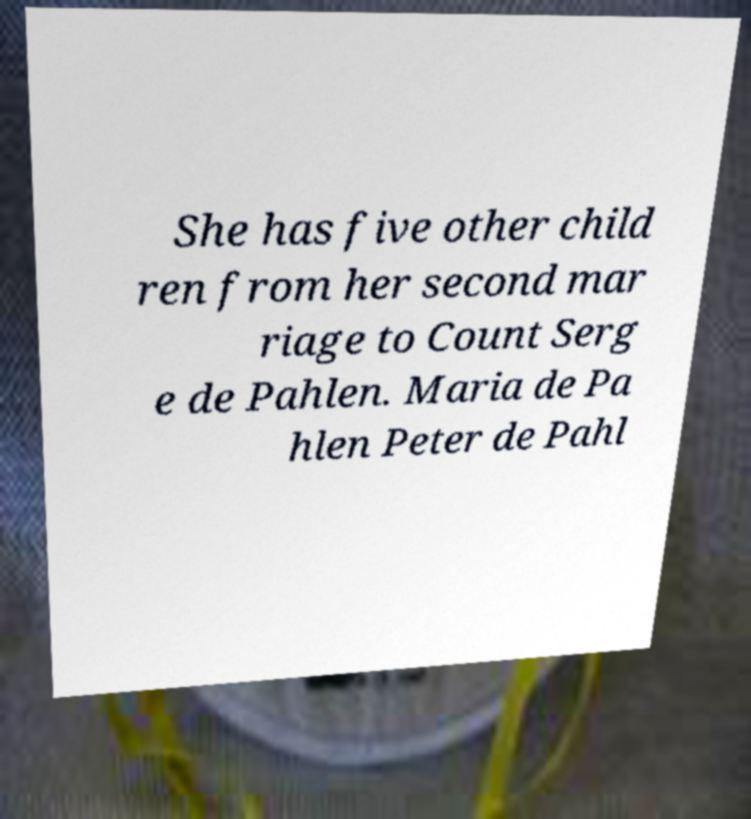Could you assist in decoding the text presented in this image and type it out clearly? She has five other child ren from her second mar riage to Count Serg e de Pahlen. Maria de Pa hlen Peter de Pahl 